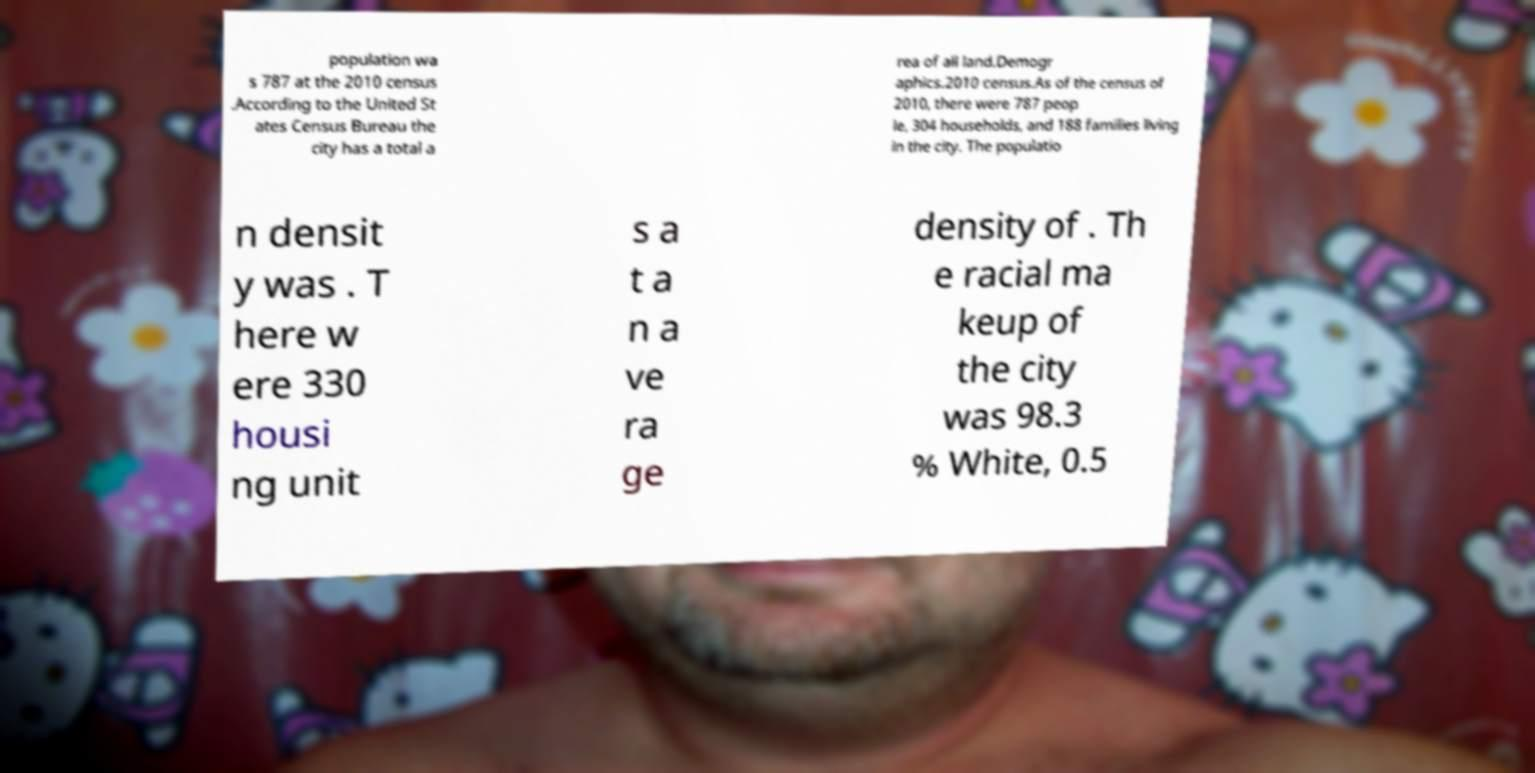For documentation purposes, I need the text within this image transcribed. Could you provide that? population wa s 787 at the 2010 census .According to the United St ates Census Bureau the city has a total a rea of all land.Demogr aphics.2010 census.As of the census of 2010, there were 787 peop le, 304 households, and 188 families living in the city. The populatio n densit y was . T here w ere 330 housi ng unit s a t a n a ve ra ge density of . Th e racial ma keup of the city was 98.3 % White, 0.5 